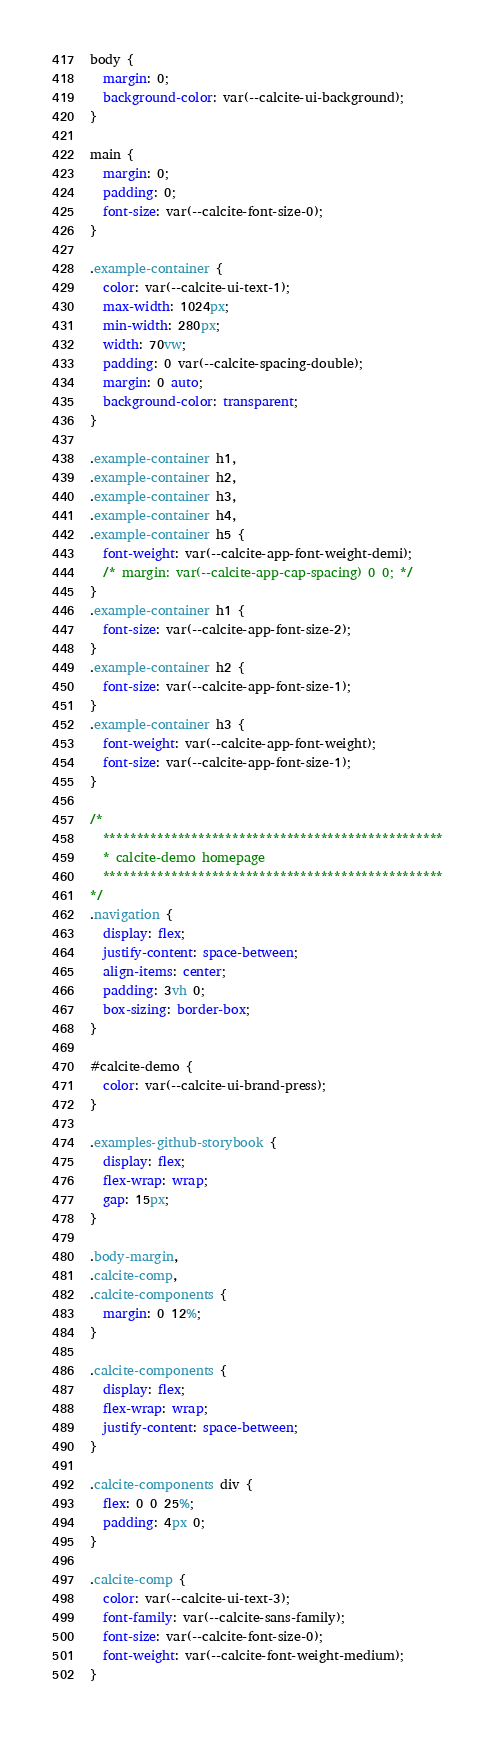Convert code to text. <code><loc_0><loc_0><loc_500><loc_500><_CSS_>body {
  margin: 0;
  background-color: var(--calcite-ui-background);
}

main {
  margin: 0;
  padding: 0;
  font-size: var(--calcite-font-size-0);
}

.example-container {
  color: var(--calcite-ui-text-1);
  max-width: 1024px;
  min-width: 280px;
  width: 70vw;
  padding: 0 var(--calcite-spacing-double);
  margin: 0 auto;
  background-color: transparent;
}

.example-container h1,
.example-container h2,
.example-container h3,
.example-container h4,
.example-container h5 {
  font-weight: var(--calcite-app-font-weight-demi);
  /* margin: var(--calcite-app-cap-spacing) 0 0; */
}
.example-container h1 {
  font-size: var(--calcite-app-font-size-2);
}
.example-container h2 {
  font-size: var(--calcite-app-font-size-1);
}
.example-container h3 {
  font-weight: var(--calcite-app-font-weight);
  font-size: var(--calcite-app-font-size-1);
}

/*
  **************************************************
  * calcite-demo homepage
  **************************************************
*/
.navigation {
  display: flex;
  justify-content: space-between;
  align-items: center;
  padding: 3vh 0;
  box-sizing: border-box;
}

#calcite-demo {
  color: var(--calcite-ui-brand-press);
}

.examples-github-storybook {
  display: flex;
  flex-wrap: wrap;
  gap: 15px;
}

.body-margin,
.calcite-comp,
.calcite-components {
  margin: 0 12%;
}

.calcite-components {
  display: flex;
  flex-wrap: wrap;
  justify-content: space-between;
}

.calcite-components div {
  flex: 0 0 25%;
  padding: 4px 0;
}

.calcite-comp {
  color: var(--calcite-ui-text-3);
  font-family: var(--calcite-sans-family);
  font-size: var(--calcite-font-size-0);
  font-weight: var(--calcite-font-weight-medium);
}
</code> 